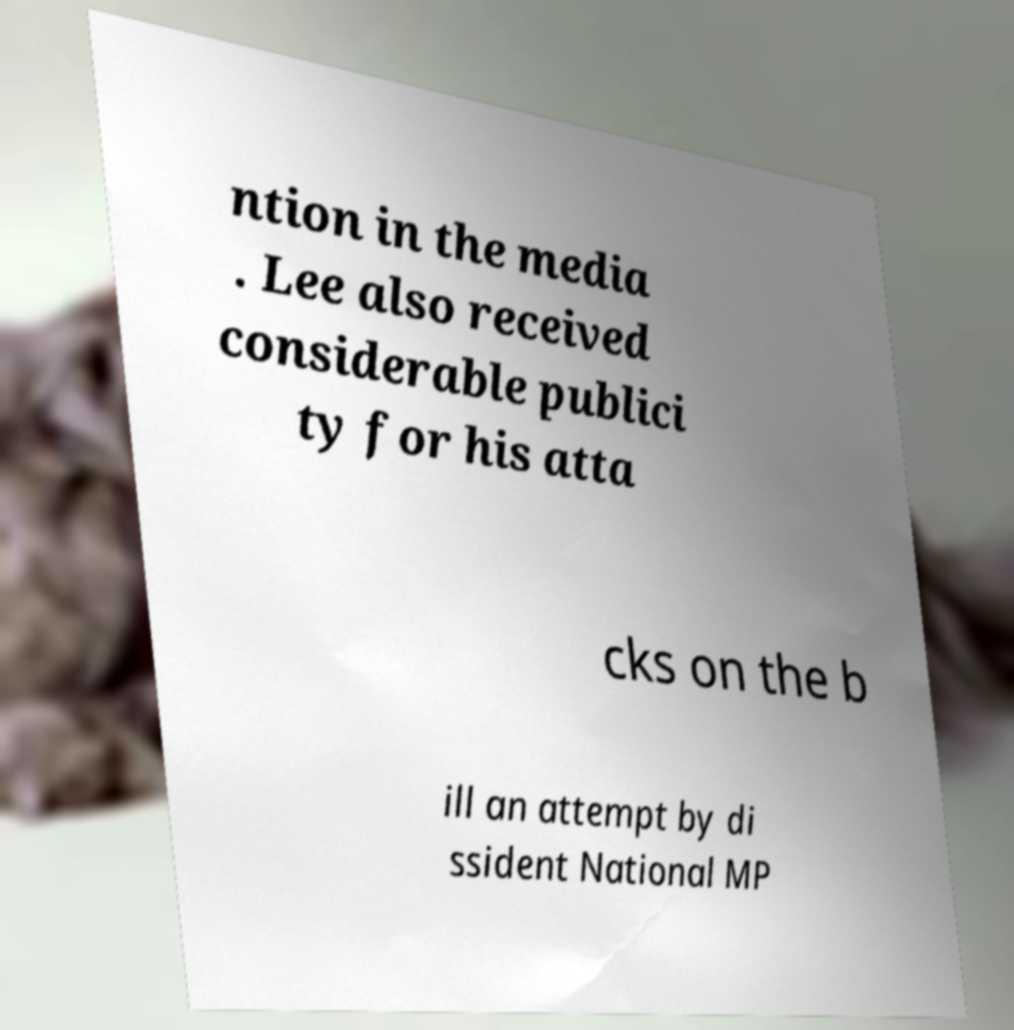Could you assist in decoding the text presented in this image and type it out clearly? ntion in the media . Lee also received considerable publici ty for his atta cks on the b ill an attempt by di ssident National MP 